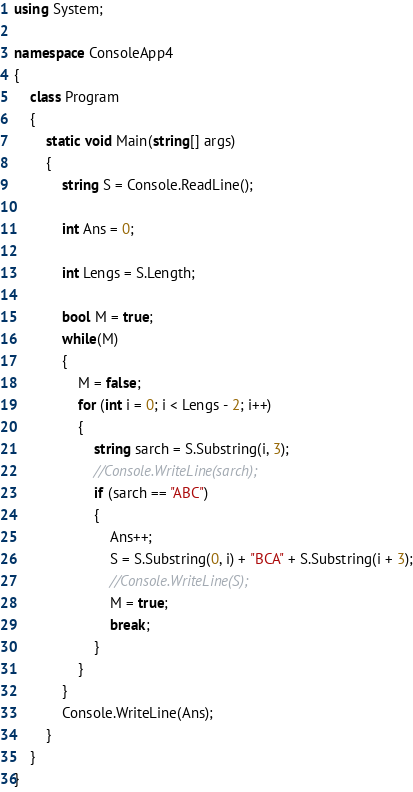<code> <loc_0><loc_0><loc_500><loc_500><_C#_>using System;

namespace ConsoleApp4
{
    class Program
    {
        static void Main(string[] args)
        {
            string S = Console.ReadLine();

            int Ans = 0;

            int Lengs = S.Length;

            bool M = true;
            while(M)
            {
                M = false;
                for (int i = 0; i < Lengs - 2; i++)
                {
                    string sarch = S.Substring(i, 3);
                    //Console.WriteLine(sarch);
                    if (sarch == "ABC")
                    {
                        Ans++;
                        S = S.Substring(0, i) + "BCA" + S.Substring(i + 3);
                        //Console.WriteLine(S);
                        M = true;
                        break;
                    }
                }
            }
            Console.WriteLine(Ans);
        }
    }
}</code> 